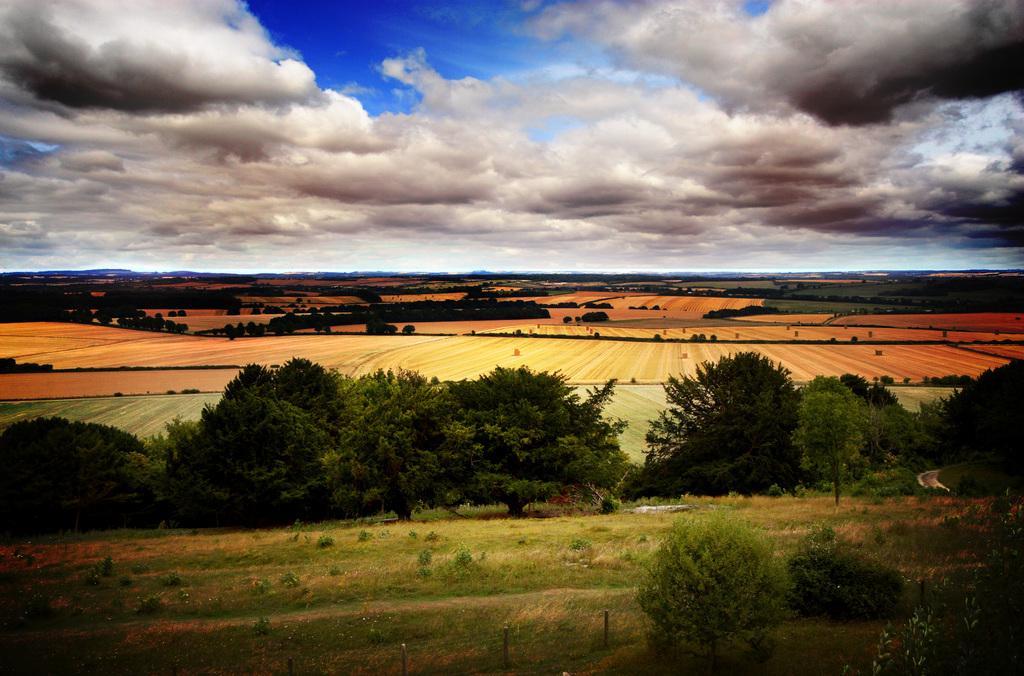How would you summarize this image in a sentence or two? In this image we can see few trees, grass, sand and the sky with clouds. 